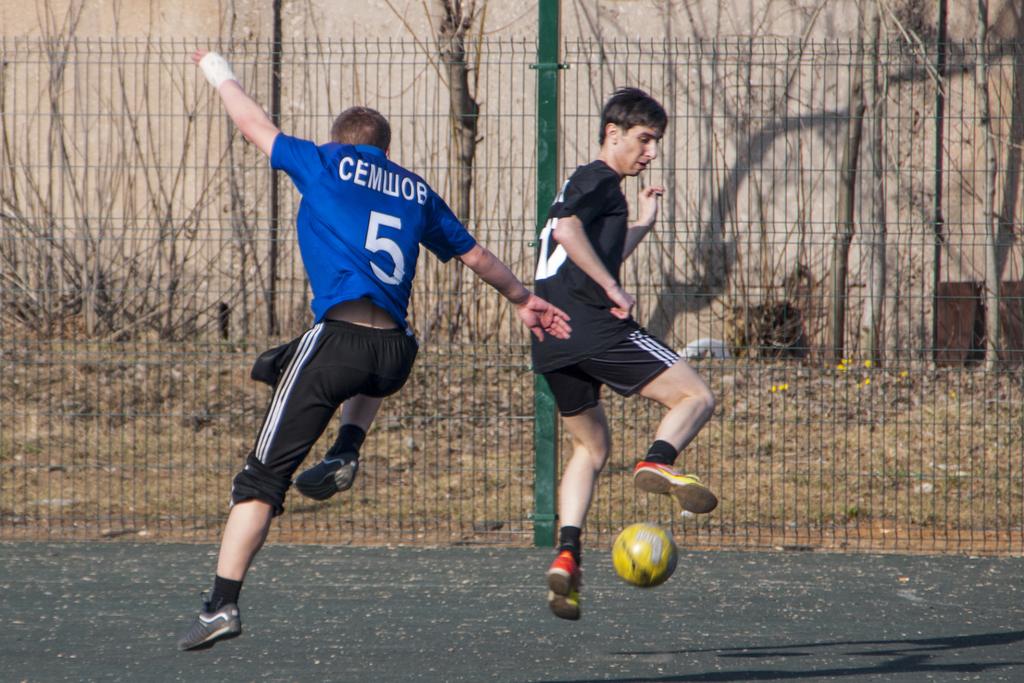What number is the player in blue?
Provide a succinct answer. 5. What name is the player in blue?
Give a very brief answer. Cemwob. 